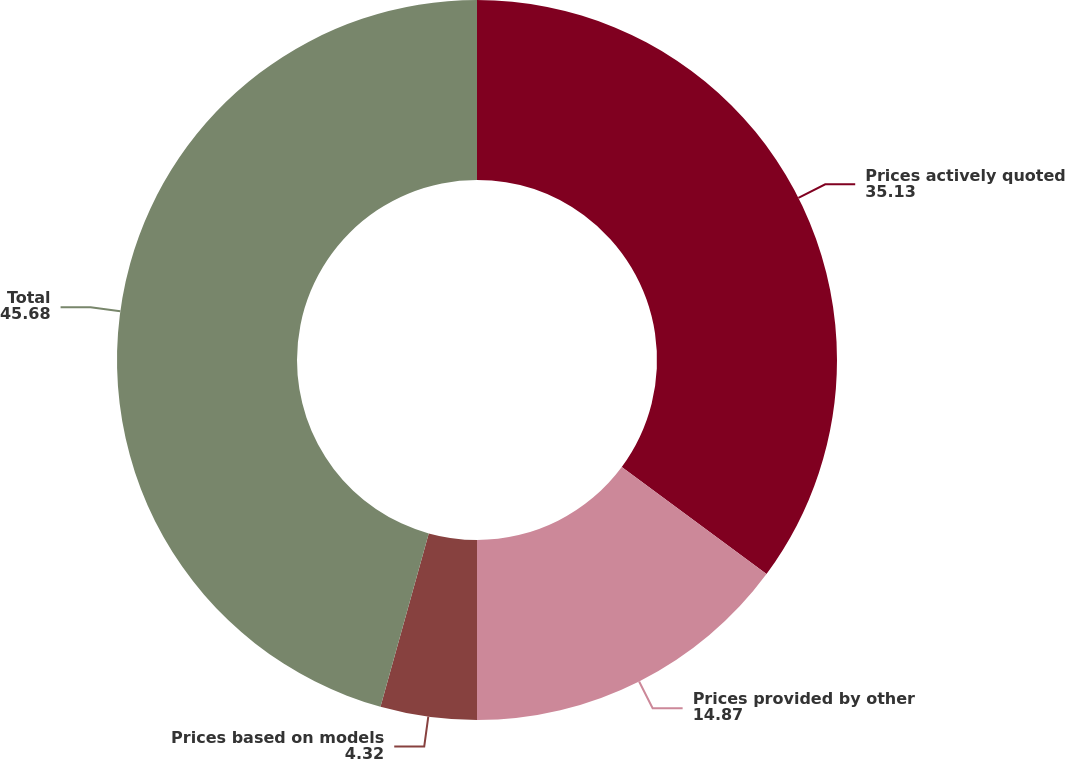Convert chart. <chart><loc_0><loc_0><loc_500><loc_500><pie_chart><fcel>Prices actively quoted<fcel>Prices provided by other<fcel>Prices based on models<fcel>Total<nl><fcel>35.13%<fcel>14.87%<fcel>4.32%<fcel>45.68%<nl></chart> 